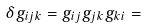Convert formula to latex. <formula><loc_0><loc_0><loc_500><loc_500>\delta g _ { i j k } = g _ { i j } g _ { j k } g _ { k i } =</formula> 